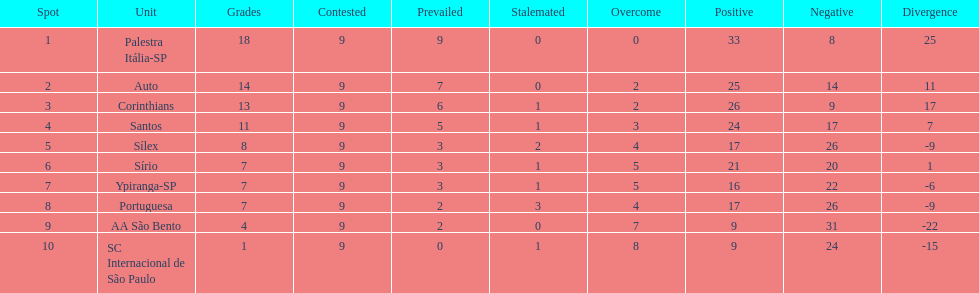In 1926 brazilian football,aside from the first place team, what other teams had winning records? Auto, Corinthians, Santos. 